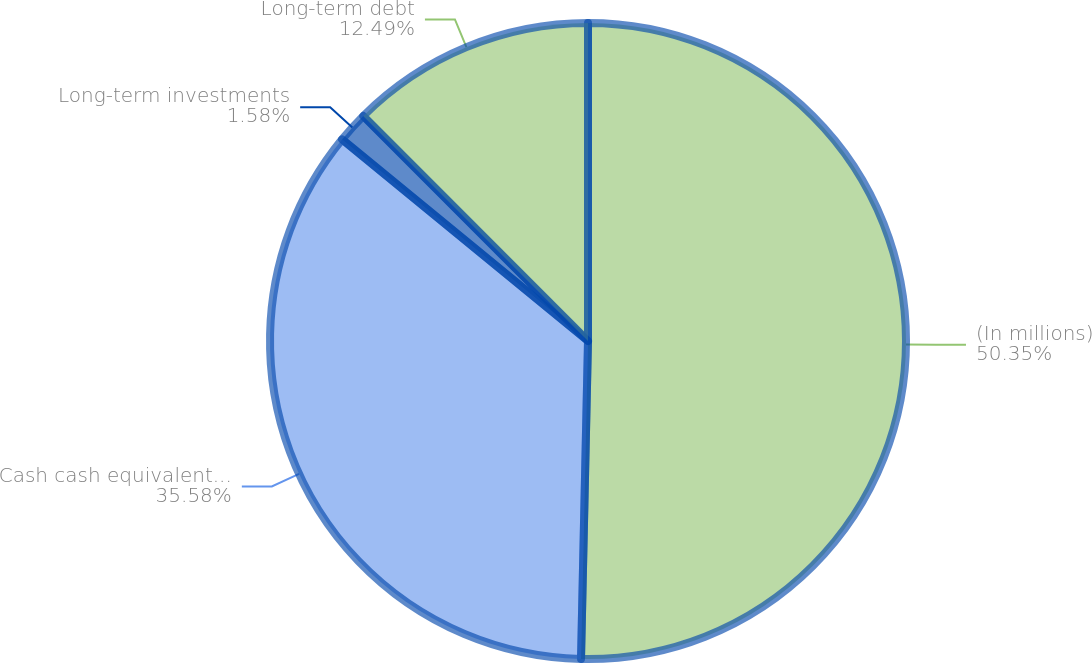Convert chart to OTSL. <chart><loc_0><loc_0><loc_500><loc_500><pie_chart><fcel>(In millions)<fcel>Cash cash equivalents and<fcel>Long-term investments<fcel>Long-term debt<nl><fcel>50.35%<fcel>35.58%<fcel>1.58%<fcel>12.49%<nl></chart> 